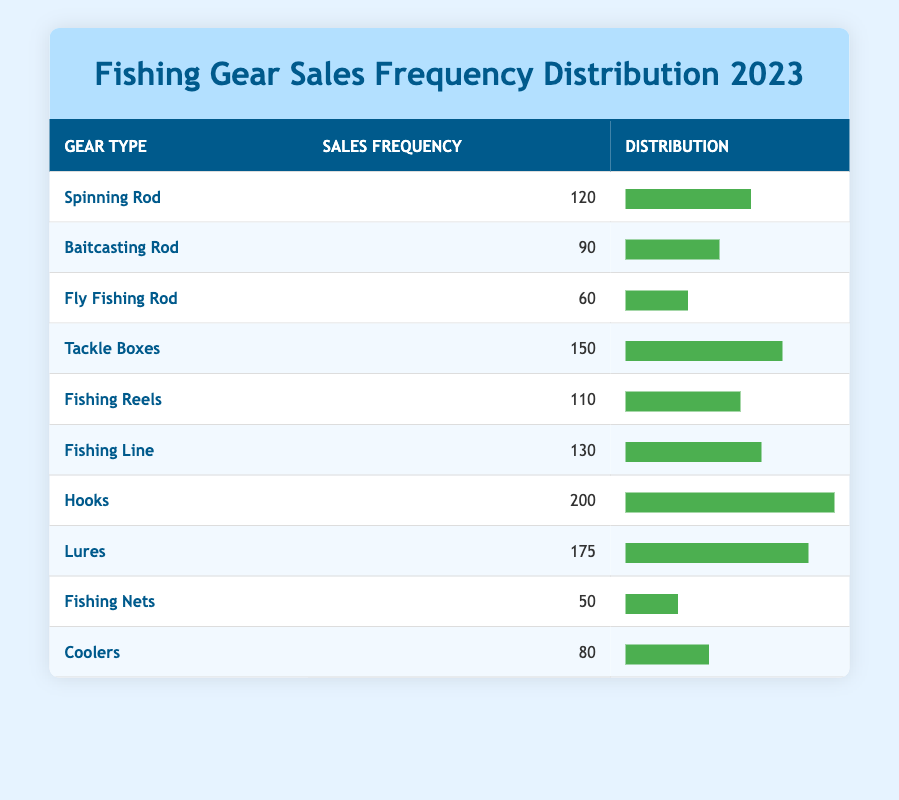What was the sales frequency for Fishing Reels? The sales frequency for Fishing Reels can be directly found in the table, where it shows "Fishing Reels" with a frequency of 110.
Answer: 110 Which fishing gear type had the highest sales frequency? By looking through the sales frequencies, the gear type with the highest frequency is "Hooks" with a count of 200.
Answer: Hooks What is the total sales frequency for Tackle Boxes and Fishing Reels combined? The sales frequency for Tackle Boxes is 150 and for Fishing Reels is 110. Adding these together gives 150 + 110 = 260.
Answer: 260 Are there more than 100 units sold for Baitcasting Rods? The sales frequency for Baitcasting Rods is 90, which is not more than 100. Thus, the answer is no.
Answer: No What is the average sales frequency of all fishing gear types listed? To find the average, we first sum all frequencies: 120 + 90 + 60 + 150 + 110 + 130 + 200 + 175 + 50 + 80 = 1,165. There are 10 gear types, so the average is 1,165 / 10 = 116.5.
Answer: 116.5 How many more units of Lures were sold than Fishing Nets? The sales frequency for Lures is 175 and for Fishing Nets is 50. The difference is 175 - 50 = 125, indicating that Lures had 125 more units sold.
Answer: 125 What proportion of sales does Fishing Line represent compared to the total sales? The sales for Fishing Line is 130. The total sales is 1,165 (as previously calculated). Therefore, the proportion is 130 / 1,165 ≈ 0.111 or 11.1%.
Answer: 11.1% Which has a greater sales frequency, Coolers or Fly Fishing Rods? Coolers have a sales frequency of 80, while Fly Fishing Rods have 60. Since 80 is greater than 60, the answer is Coolers.
Answer: Coolers If we combine the sales of Spinning Rod, Fishing Reels, and Fishing Line, what will be the total frequency? The sales frequencies are Spinning Rod (120), Fishing Reels (110), and Fishing Line (130). Adding these gives 120 + 110 + 130 = 360.
Answer: 360 